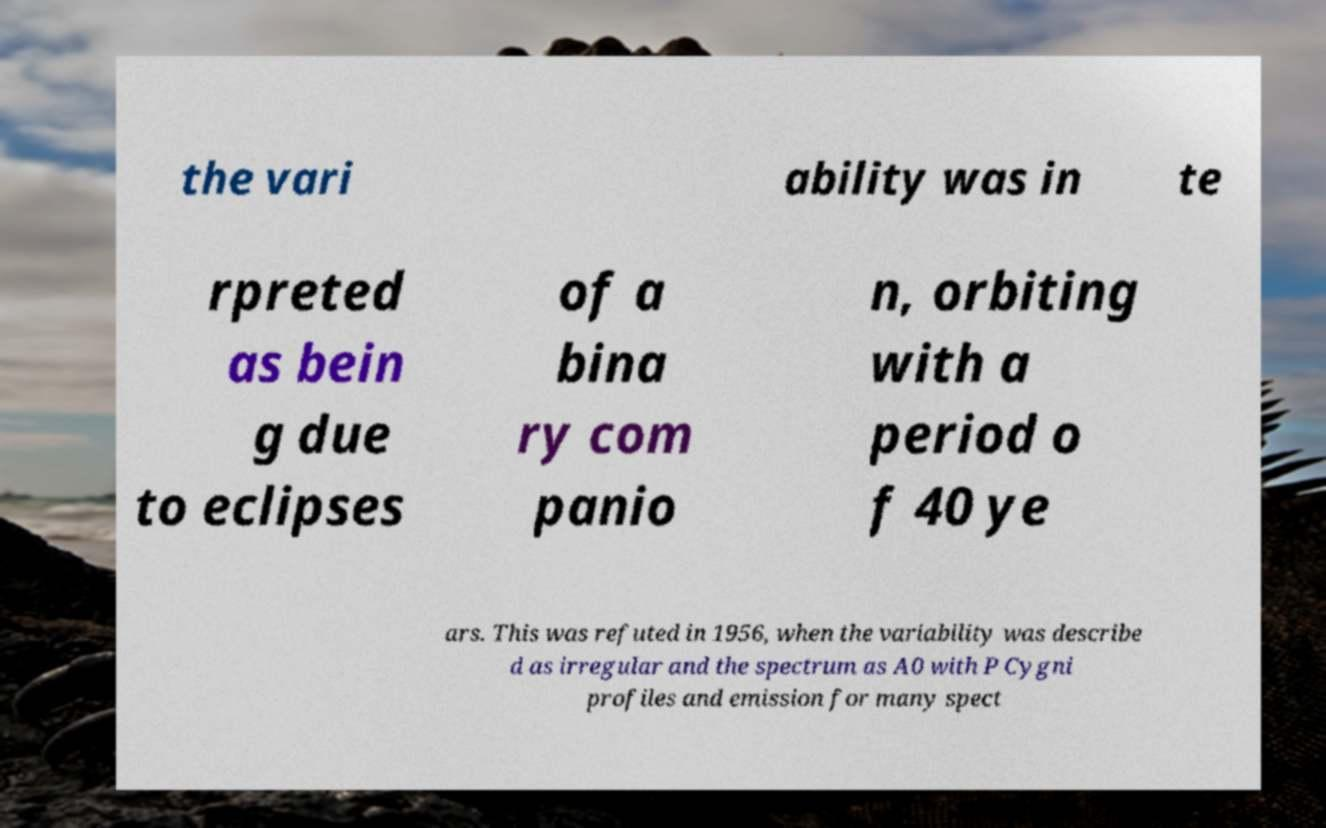I need the written content from this picture converted into text. Can you do that? the vari ability was in te rpreted as bein g due to eclipses of a bina ry com panio n, orbiting with a period o f 40 ye ars. This was refuted in 1956, when the variability was describe d as irregular and the spectrum as A0 with P Cygni profiles and emission for many spect 